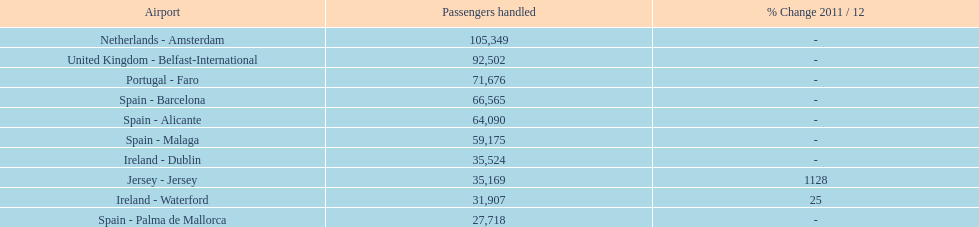Could you parse the entire table? {'header': ['Airport', 'Passengers handled', '% Change 2011 / 12'], 'rows': [['Netherlands - Amsterdam', '105,349', '-'], ['United Kingdom - Belfast-International', '92,502', '-'], ['Portugal - Faro', '71,676', '-'], ['Spain - Barcelona', '66,565', '-'], ['Spain - Alicante', '64,090', '-'], ['Spain - Malaga', '59,175', '-'], ['Ireland - Dublin', '35,524', '-'], ['Jersey - Jersey', '35,169', '1128'], ['Ireland - Waterford', '31,907', '25'], ['Spain - Palma de Mallorca', '27,718', '-']]} At a spanish airport, how many passengers were processed? 217,548. 